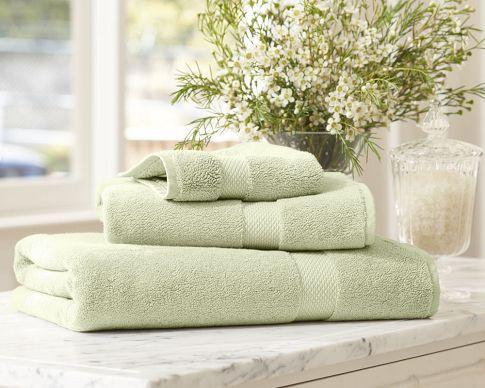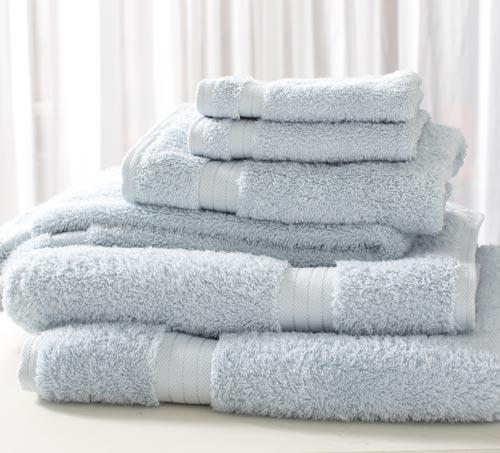The first image is the image on the left, the second image is the image on the right. Analyze the images presented: Is the assertion "A towel pile includes white towels with contrast stripe trim." valid? Answer yes or no. No. 